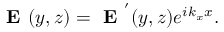Convert formula to latex. <formula><loc_0><loc_0><loc_500><loc_500>E ( y , z ) = E ^ { ^ { \prime } } ( y , z ) e ^ { i k _ { x } x } .</formula> 